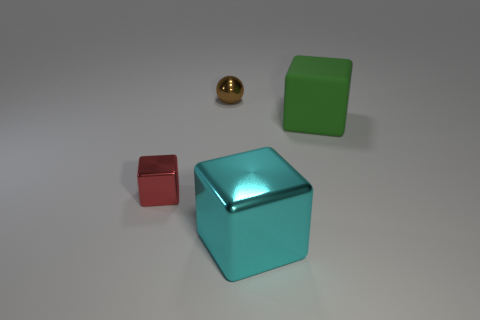Add 4 large gray rubber cylinders. How many objects exist? 8 Subtract all spheres. How many objects are left? 3 Subtract 1 brown spheres. How many objects are left? 3 Subtract all small metallic spheres. Subtract all small red metal objects. How many objects are left? 2 Add 1 small balls. How many small balls are left? 2 Add 2 small yellow objects. How many small yellow objects exist? 2 